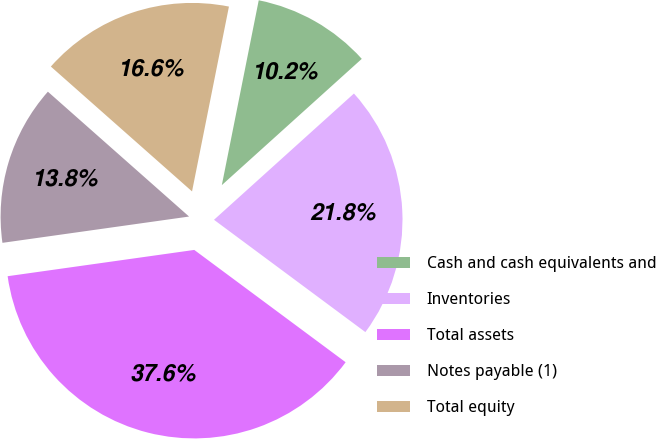<chart> <loc_0><loc_0><loc_500><loc_500><pie_chart><fcel>Cash and cash equivalents and<fcel>Inventories<fcel>Total assets<fcel>Notes payable (1)<fcel>Total equity<nl><fcel>10.18%<fcel>21.84%<fcel>37.61%<fcel>13.75%<fcel>16.61%<nl></chart> 